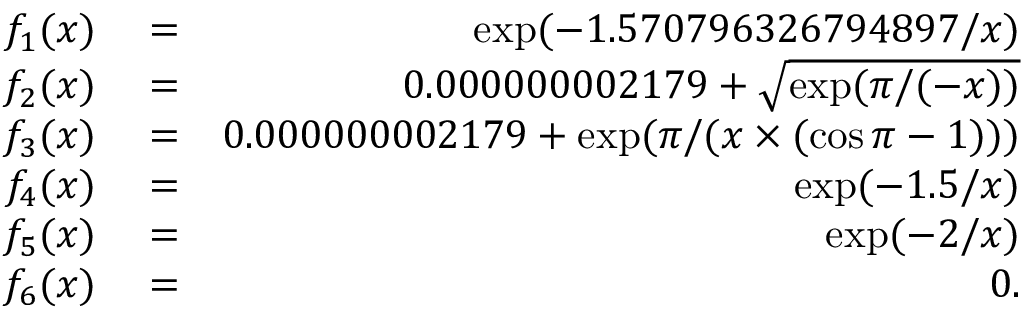<formula> <loc_0><loc_0><loc_500><loc_500>\begin{array} { r l r } { f _ { 1 } ( x ) } & = } & { \exp ( - 1 . 5 7 0 7 9 6 3 2 6 7 9 4 8 9 7 / x ) } \\ { f _ { 2 } ( x ) } & = } & { 0 . 0 0 0 0 0 0 0 0 2 1 7 9 + \sqrt { \exp ( \pi / ( - x ) ) } } \\ { f _ { 3 } ( x ) } & = } & { 0 . 0 0 0 0 0 0 0 0 2 1 7 9 + \exp ( \pi / ( x \times ( \cos \pi - 1 ) ) ) } \\ { f _ { 4 } ( x ) } & = } & { \exp ( - 1 . 5 / x ) } \\ { f _ { 5 } ( x ) } & = } & { \exp ( - 2 / x ) } \\ { f _ { 6 } ( x ) } & = } & { 0 . } \end{array}</formula> 